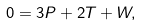<formula> <loc_0><loc_0><loc_500><loc_500>0 & = 3 P + 2 T + W ,</formula> 